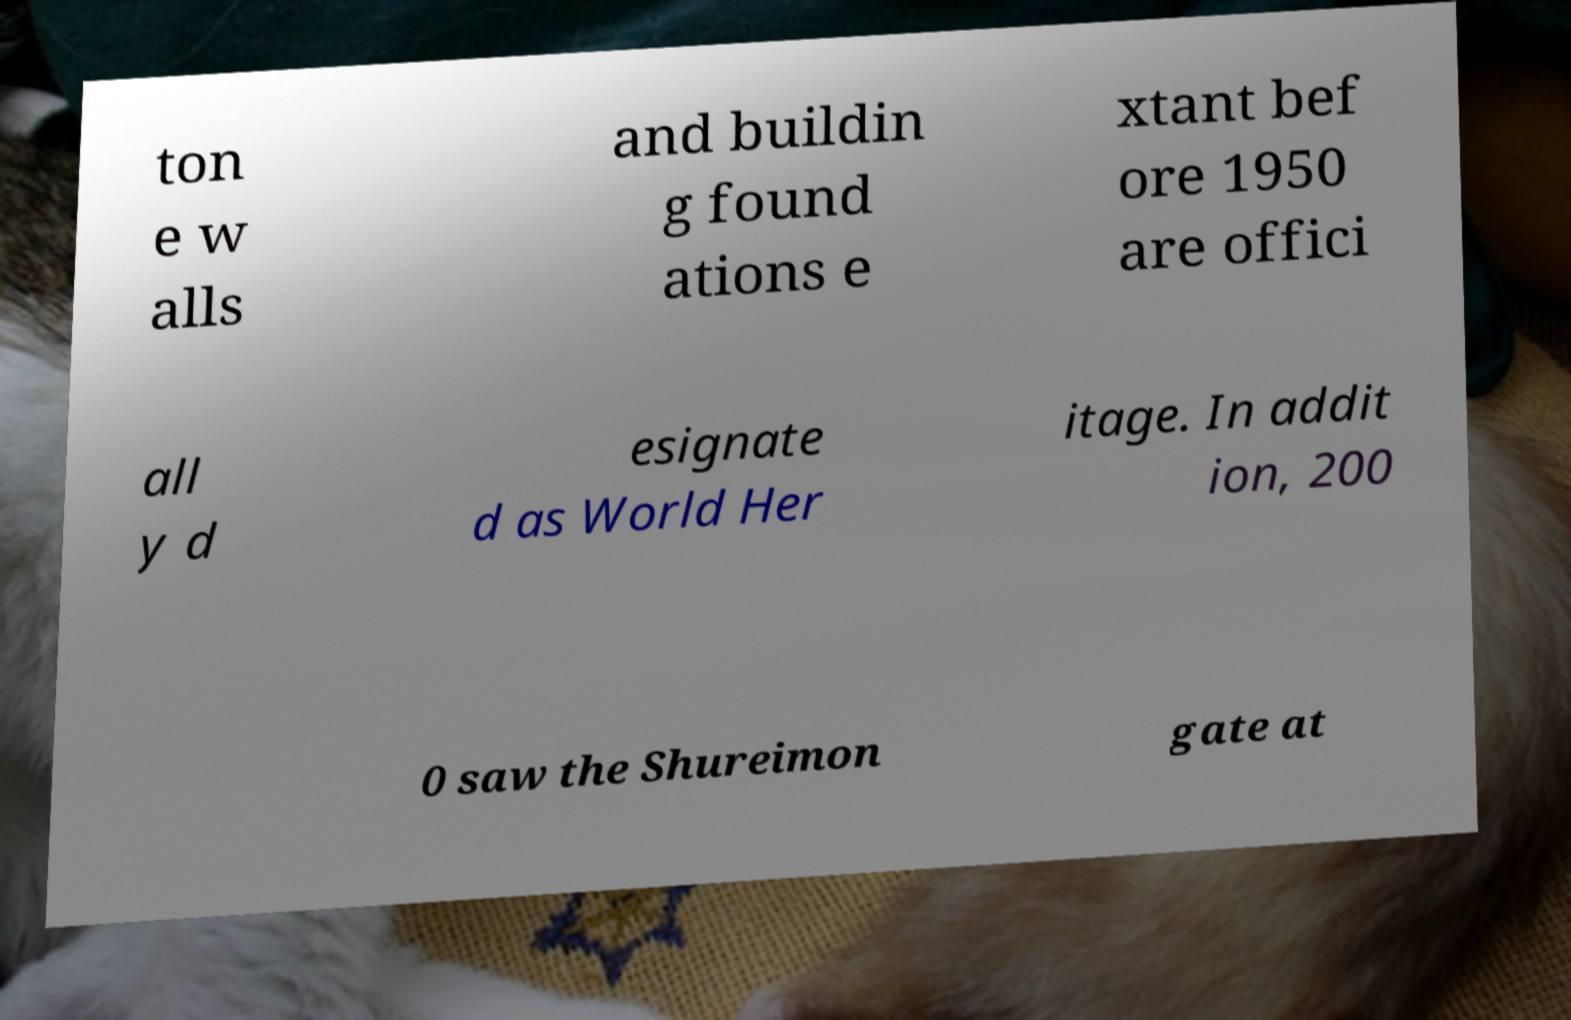I need the written content from this picture converted into text. Can you do that? ton e w alls and buildin g found ations e xtant bef ore 1950 are offici all y d esignate d as World Her itage. In addit ion, 200 0 saw the Shureimon gate at 